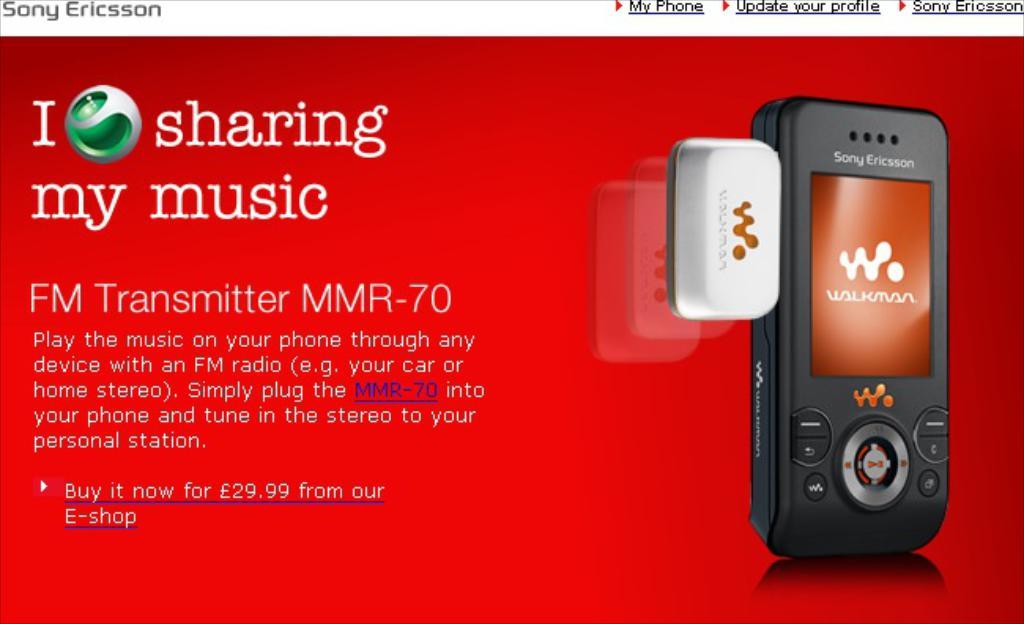What do they love sharing?
Make the answer very short. Music. What is this?
Ensure brevity in your answer.  Fm transmitter. 